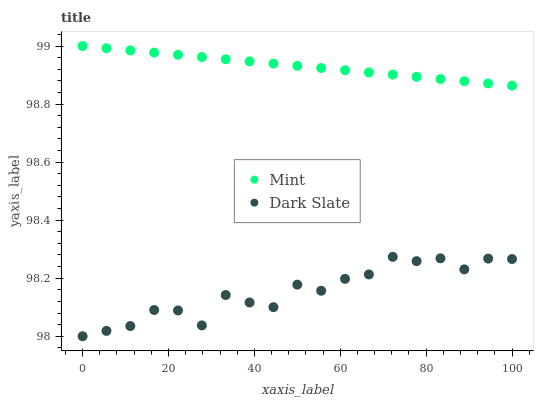Does Dark Slate have the minimum area under the curve?
Answer yes or no. Yes. Does Mint have the maximum area under the curve?
Answer yes or no. Yes. Does Mint have the minimum area under the curve?
Answer yes or no. No. Is Mint the smoothest?
Answer yes or no. Yes. Is Dark Slate the roughest?
Answer yes or no. Yes. Is Mint the roughest?
Answer yes or no. No. Does Dark Slate have the lowest value?
Answer yes or no. Yes. Does Mint have the lowest value?
Answer yes or no. No. Does Mint have the highest value?
Answer yes or no. Yes. Is Dark Slate less than Mint?
Answer yes or no. Yes. Is Mint greater than Dark Slate?
Answer yes or no. Yes. Does Dark Slate intersect Mint?
Answer yes or no. No. 